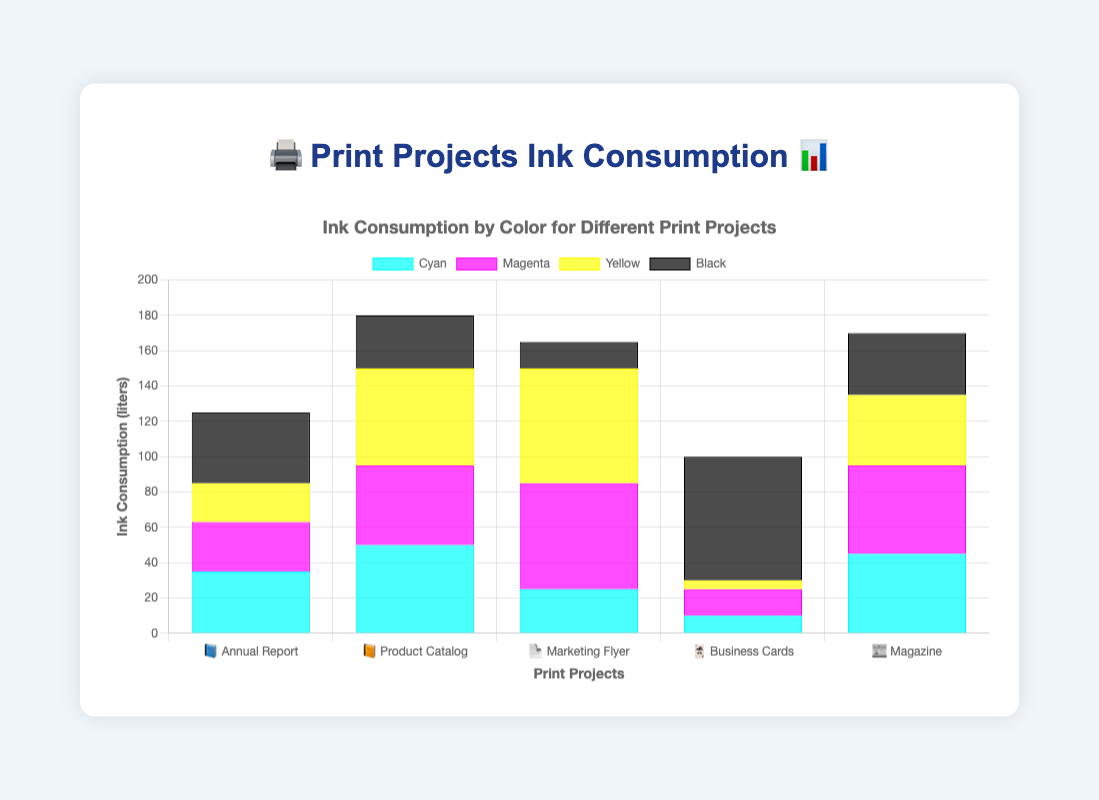What is the total ink consumption for the Annual Report project? 📘 The Annual Report uses 35 liters of Cyan, 28 liters of Magenta, 22 liters of Yellow, and 40 liters of Black. Adding these values gives 35 + 28 + 22 + 40 = 125
Answer: 125 liters Which project uses the most Magenta ink? The Magenta ink usage is: Annual Report (28), Product Catalog (45), Marketing Flyer (60), Business Cards (15), and Magazine (50). The highest usage is 60 liters for the Marketing Flyer.
Answer: Marketing Flyer How much more Yellow ink does the Marketing Flyer use compared to the Business Cards? Marketing Flyer uses 65 liters, and Business Cards use 5 liters of Yellow ink. The difference is 65 - 5 = 60 liters.
Answer: 60 liters What is the average Black ink consumption across all projects? Sum of Black ink across all projects is 40 + 30 + 15 + 70 + 35 = 190 liters. There are 5 projects, so the average is 190 / 5 = 38 liters.
Answer: 38 liters Which projects use less than 40 liters of Cyan ink? Checking the Cyan ink usage: Annual Report (35), Product Catalog (50), Marketing Flyer (25), Business Cards (10), and Magazine (45). The projects using less than 40 liters are Annual Report, Marketing Flyer, and Business Cards.
Answer: Annual Report, Marketing Flyer, Business Cards How many projects use more Cyan ink than Black ink? Comparing usage: Annual Report (Cyan 35, Black 40), Product Catalog (Cyan 50, Black 30), Marketing Flyer (Cyan 25, Black 15), Business Cards (Cyan 10, Black 70), Magazine (Cyan 45, Black 35). Projects where Cyan is more are Product Catalog, Marketing Flyer, and Magazine.
Answer: 3 projects Which color has the highest total consumption across all projects? Summing up the consumption by color: Cyan (35+50+25+10+45=165), Magenta (28+45+60+15+50=198), Yellow (22+55+65+5+40=187), Black (40+30+15+70+35=190). The highest total consumption is Magenta with 198 liters.
Answer: Magenta What is the difference in total ink consumption between the Product Catalog and Business Cards? Total for Product Catalog (50+45+55+30 = 180), Total for Business Cards (10+15+5+70 = 100). The difference is 180 - 100 = 80 liters.
Answer: 80 liters Which project has the lowest overall ink consumption? Summing the total for each project: Annual Report (125), Product Catalog (180), Marketing Flyer (165), Business Cards (100), Magazine (170). The lowest total is Business Cards with 100 liters.
Answer: Business Cards 